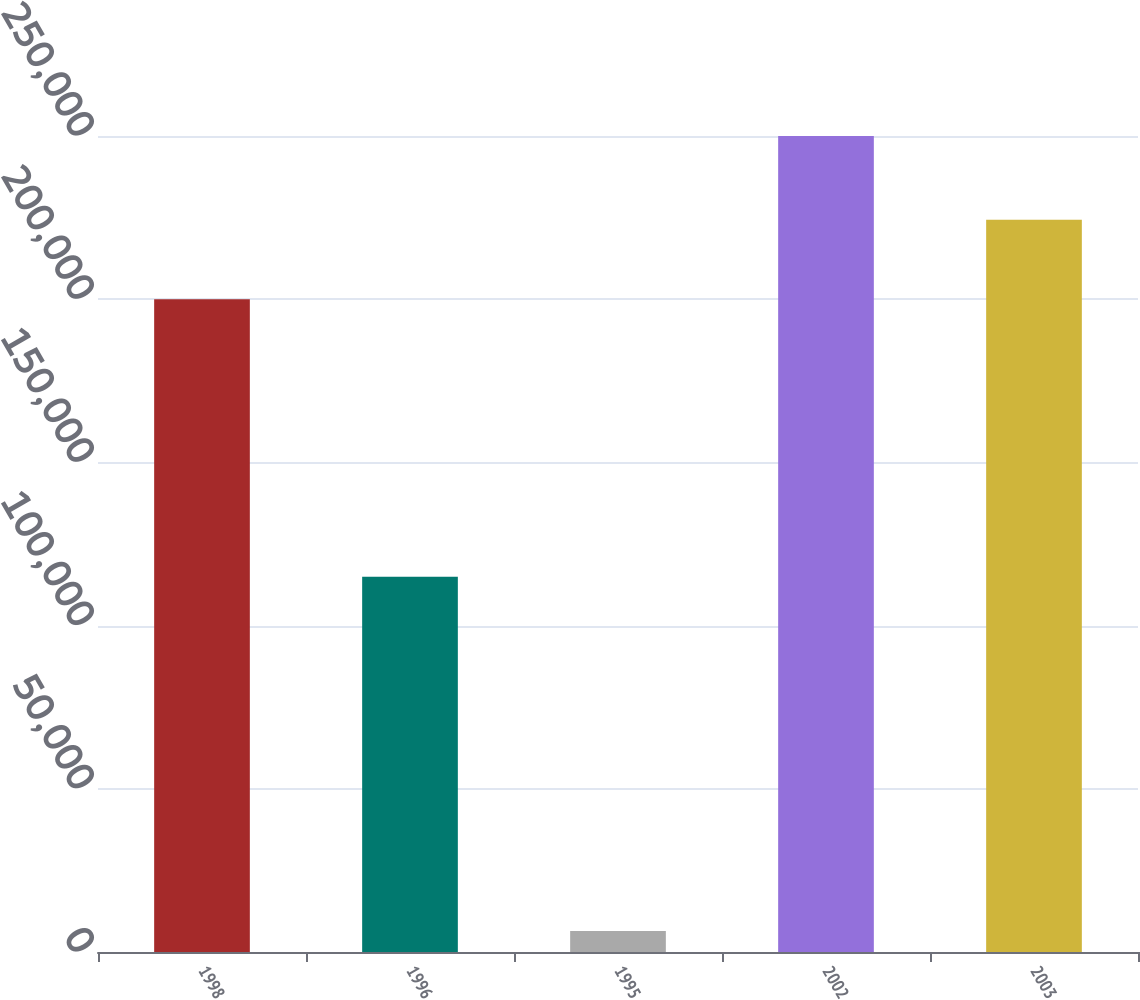Convert chart. <chart><loc_0><loc_0><loc_500><loc_500><bar_chart><fcel>1998<fcel>1996<fcel>1995<fcel>2002<fcel>2003<nl><fcel>200000<fcel>115000<fcel>6421<fcel>250000<fcel>224358<nl></chart> 